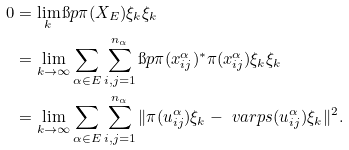<formula> <loc_0><loc_0><loc_500><loc_500>0 & = \lim _ { k } \i p { \pi ( X _ { E } ) \xi _ { k } } { \xi _ { k } } \\ & = \lim _ { k \to \infty } \sum _ { \alpha \in E } \sum _ { i , j = 1 } ^ { n _ { \alpha } } \i p { \pi ( x _ { i j } ^ { \alpha } ) ^ { * } \pi ( x _ { i j } ^ { \alpha } ) \xi _ { k } } { \xi _ { k } } \\ & = \lim _ { k \to \infty } \sum _ { \alpha \in E } \sum _ { i , j = 1 } ^ { n _ { \alpha } } \| \pi ( u _ { i j } ^ { \alpha } ) \xi _ { k } - \ v a r p s ( u _ { i j } ^ { \alpha } ) \xi _ { k } \| ^ { 2 } .</formula> 